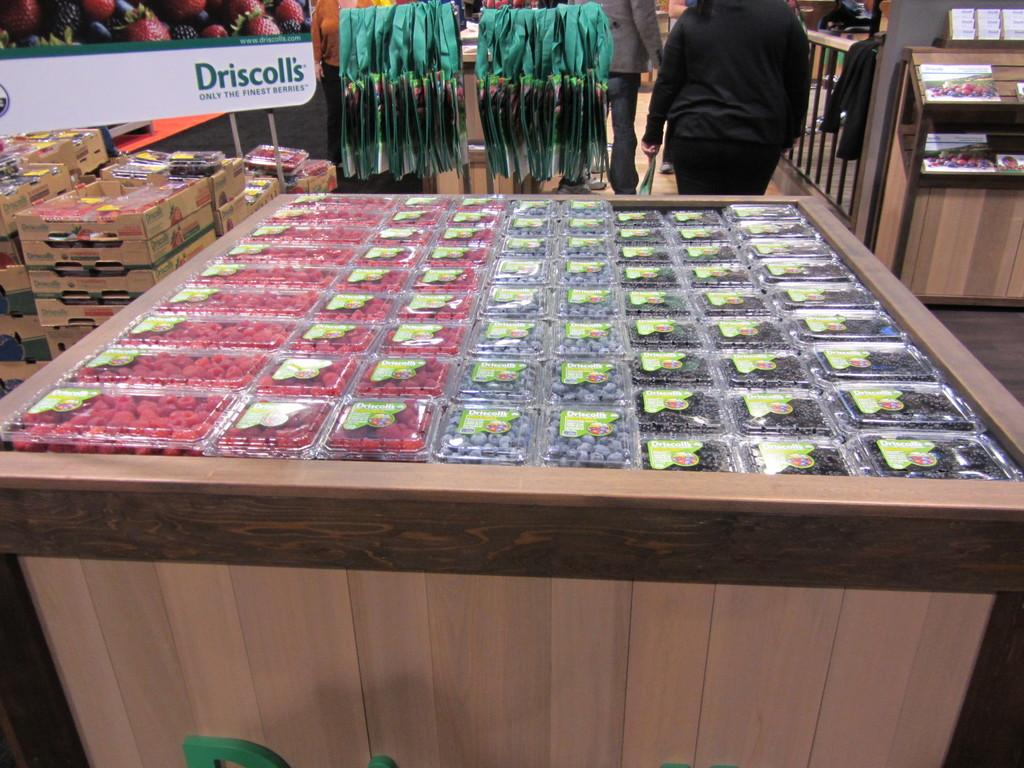<image>
Create a compact narrative representing the image presented. Driscoll's brand named berries in a super market display. 